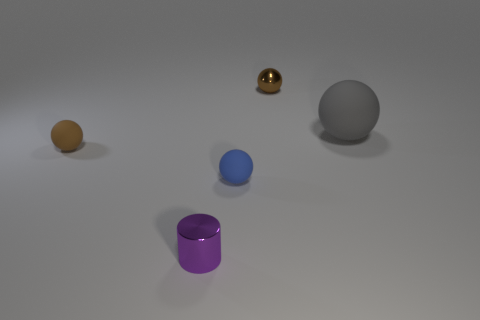Subtract all brown spheres. How many were subtracted if there are1brown spheres left? 1 Subtract all tiny blue balls. How many balls are left? 3 Add 3 brown things. How many objects exist? 8 Subtract all blue balls. How many balls are left? 3 Subtract all cylinders. How many objects are left? 4 Subtract all red cylinders. How many brown balls are left? 2 Subtract all gray matte objects. Subtract all rubber things. How many objects are left? 1 Add 2 tiny blue matte objects. How many tiny blue matte objects are left? 3 Add 4 cylinders. How many cylinders exist? 5 Subtract 0 yellow cubes. How many objects are left? 5 